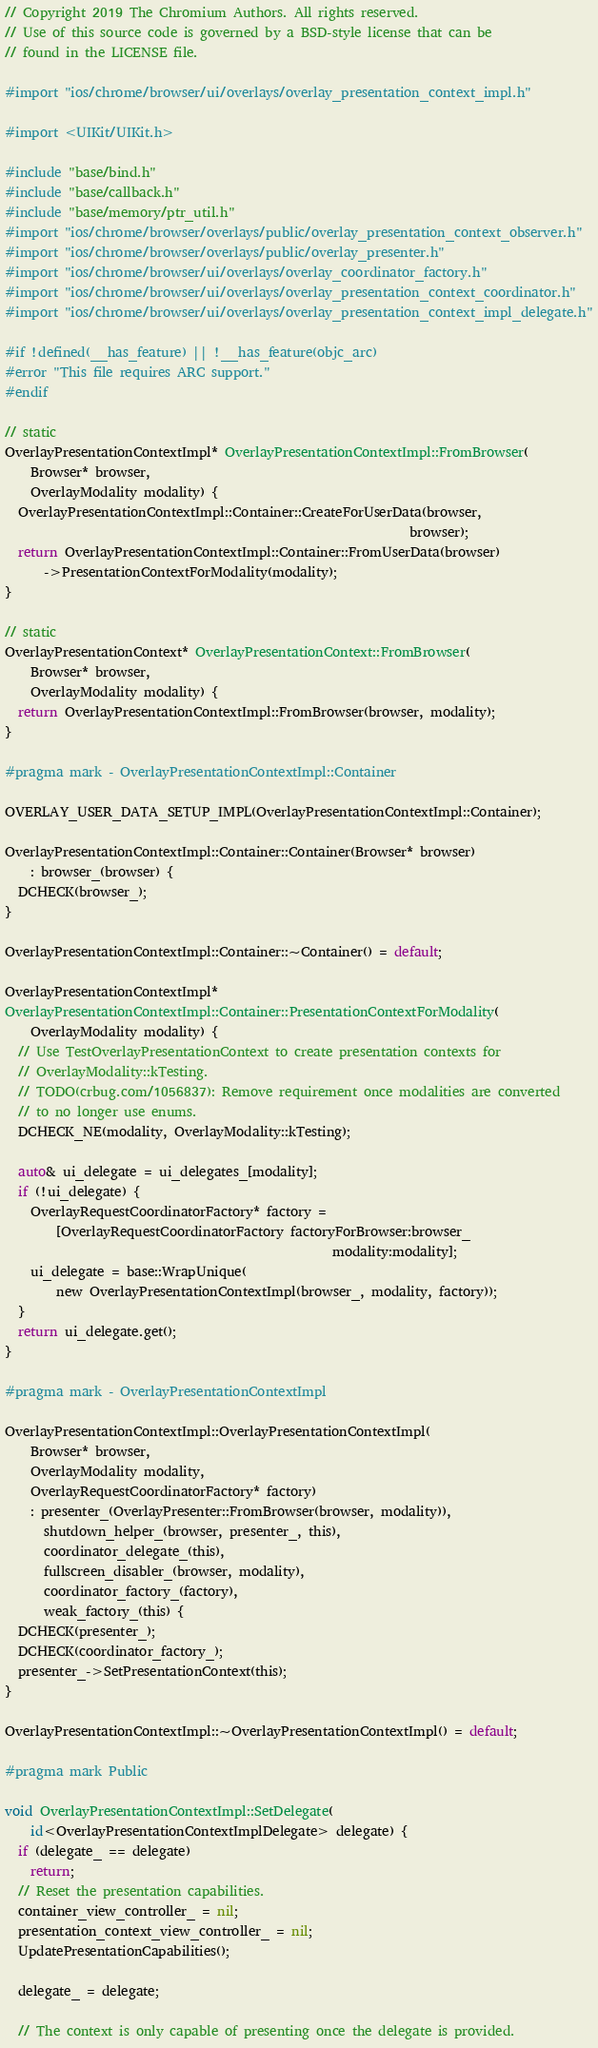Convert code to text. <code><loc_0><loc_0><loc_500><loc_500><_ObjectiveC_>// Copyright 2019 The Chromium Authors. All rights reserved.
// Use of this source code is governed by a BSD-style license that can be
// found in the LICENSE file.

#import "ios/chrome/browser/ui/overlays/overlay_presentation_context_impl.h"

#import <UIKit/UIKit.h>

#include "base/bind.h"
#include "base/callback.h"
#include "base/memory/ptr_util.h"
#import "ios/chrome/browser/overlays/public/overlay_presentation_context_observer.h"
#import "ios/chrome/browser/overlays/public/overlay_presenter.h"
#import "ios/chrome/browser/ui/overlays/overlay_coordinator_factory.h"
#import "ios/chrome/browser/ui/overlays/overlay_presentation_context_coordinator.h"
#import "ios/chrome/browser/ui/overlays/overlay_presentation_context_impl_delegate.h"

#if !defined(__has_feature) || !__has_feature(objc_arc)
#error "This file requires ARC support."
#endif

// static
OverlayPresentationContextImpl* OverlayPresentationContextImpl::FromBrowser(
    Browser* browser,
    OverlayModality modality) {
  OverlayPresentationContextImpl::Container::CreateForUserData(browser,
                                                               browser);
  return OverlayPresentationContextImpl::Container::FromUserData(browser)
      ->PresentationContextForModality(modality);
}

// static
OverlayPresentationContext* OverlayPresentationContext::FromBrowser(
    Browser* browser,
    OverlayModality modality) {
  return OverlayPresentationContextImpl::FromBrowser(browser, modality);
}

#pragma mark - OverlayPresentationContextImpl::Container

OVERLAY_USER_DATA_SETUP_IMPL(OverlayPresentationContextImpl::Container);

OverlayPresentationContextImpl::Container::Container(Browser* browser)
    : browser_(browser) {
  DCHECK(browser_);
}

OverlayPresentationContextImpl::Container::~Container() = default;

OverlayPresentationContextImpl*
OverlayPresentationContextImpl::Container::PresentationContextForModality(
    OverlayModality modality) {
  // Use TestOverlayPresentationContext to create presentation contexts for
  // OverlayModality::kTesting.
  // TODO(crbug.com/1056837): Remove requirement once modalities are converted
  // to no longer use enums.
  DCHECK_NE(modality, OverlayModality::kTesting);

  auto& ui_delegate = ui_delegates_[modality];
  if (!ui_delegate) {
    OverlayRequestCoordinatorFactory* factory =
        [OverlayRequestCoordinatorFactory factoryForBrowser:browser_
                                                   modality:modality];
    ui_delegate = base::WrapUnique(
        new OverlayPresentationContextImpl(browser_, modality, factory));
  }
  return ui_delegate.get();
}

#pragma mark - OverlayPresentationContextImpl

OverlayPresentationContextImpl::OverlayPresentationContextImpl(
    Browser* browser,
    OverlayModality modality,
    OverlayRequestCoordinatorFactory* factory)
    : presenter_(OverlayPresenter::FromBrowser(browser, modality)),
      shutdown_helper_(browser, presenter_, this),
      coordinator_delegate_(this),
      fullscreen_disabler_(browser, modality),
      coordinator_factory_(factory),
      weak_factory_(this) {
  DCHECK(presenter_);
  DCHECK(coordinator_factory_);
  presenter_->SetPresentationContext(this);
}

OverlayPresentationContextImpl::~OverlayPresentationContextImpl() = default;

#pragma mark Public

void OverlayPresentationContextImpl::SetDelegate(
    id<OverlayPresentationContextImplDelegate> delegate) {
  if (delegate_ == delegate)
    return;
  // Reset the presentation capabilities.
  container_view_controller_ = nil;
  presentation_context_view_controller_ = nil;
  UpdatePresentationCapabilities();

  delegate_ = delegate;

  // The context is only capable of presenting once the delegate is provided.</code> 